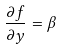Convert formula to latex. <formula><loc_0><loc_0><loc_500><loc_500>\frac { \partial f } { \partial y } = \beta</formula> 